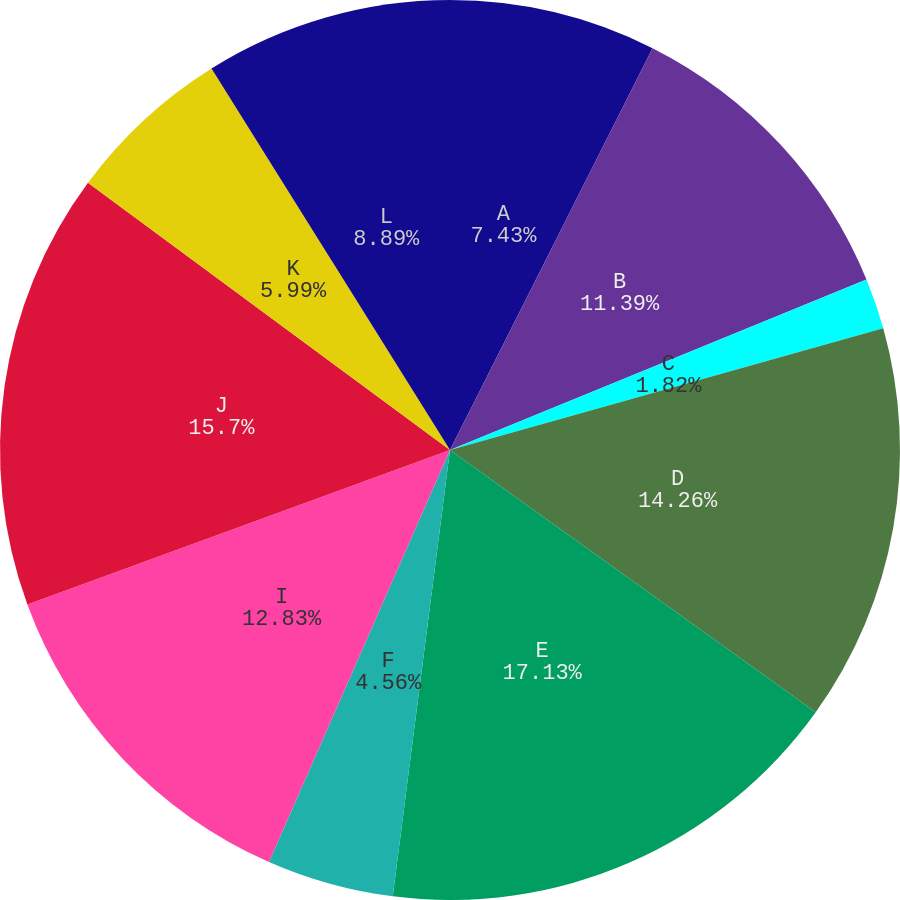Convert chart to OTSL. <chart><loc_0><loc_0><loc_500><loc_500><pie_chart><fcel>A<fcel>B<fcel>C<fcel>D<fcel>E<fcel>F<fcel>I<fcel>J<fcel>K<fcel>L<nl><fcel>7.43%<fcel>11.39%<fcel>1.82%<fcel>14.26%<fcel>17.13%<fcel>4.56%<fcel>12.83%<fcel>15.7%<fcel>5.99%<fcel>8.89%<nl></chart> 